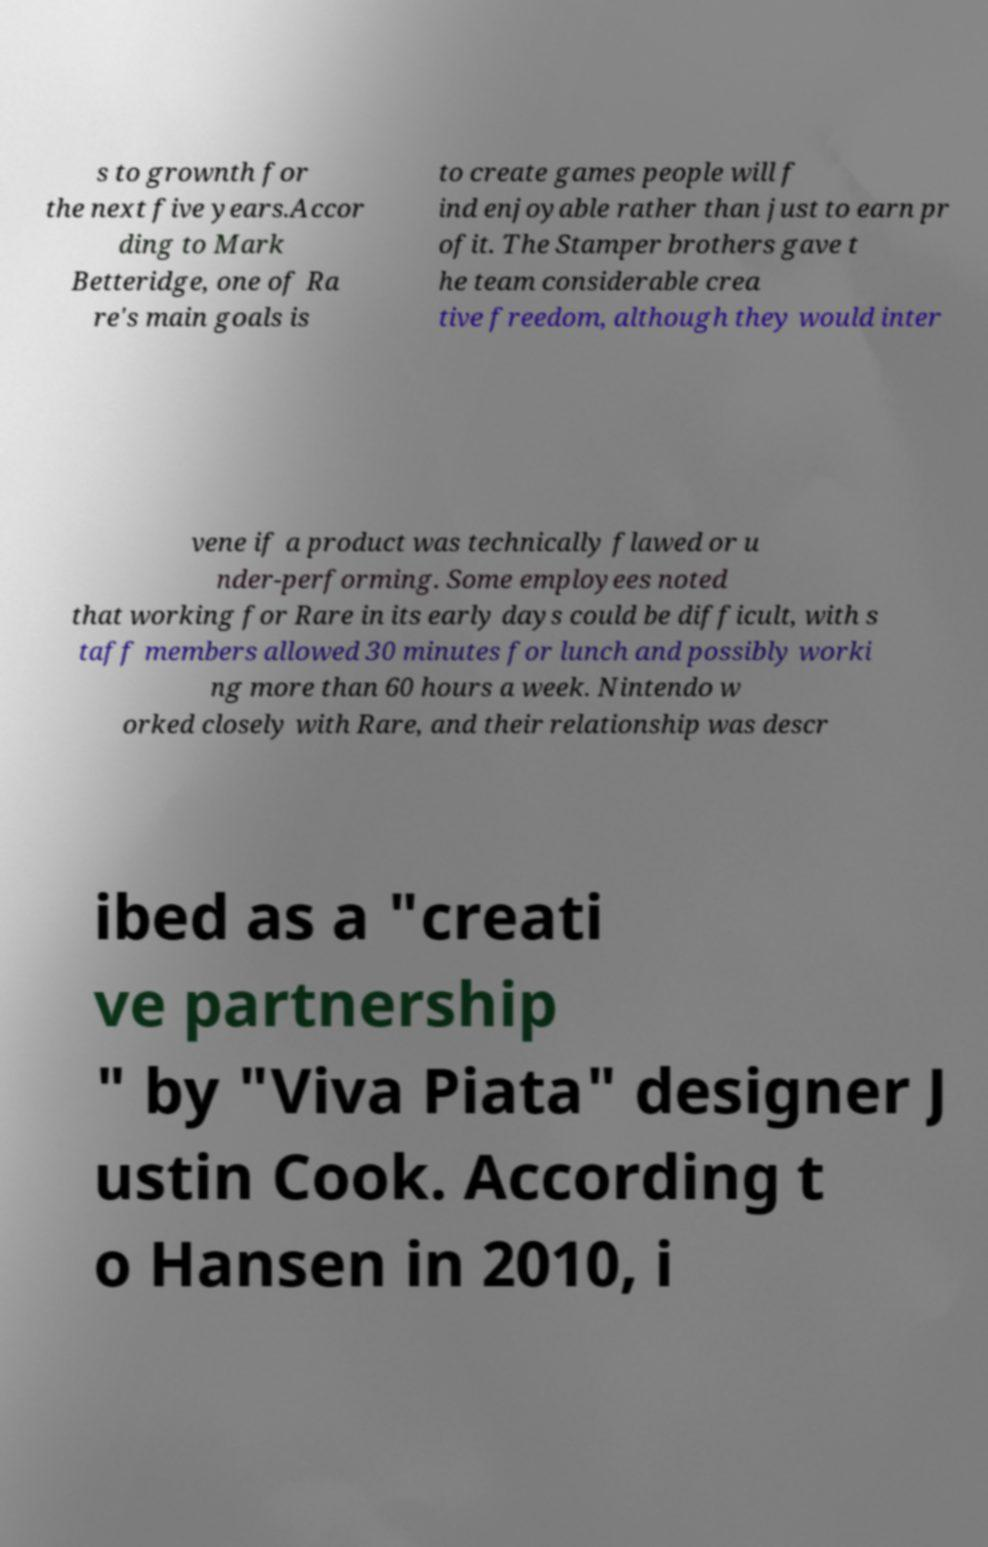Could you assist in decoding the text presented in this image and type it out clearly? s to grownth for the next five years.Accor ding to Mark Betteridge, one of Ra re's main goals is to create games people will f ind enjoyable rather than just to earn pr ofit. The Stamper brothers gave t he team considerable crea tive freedom, although they would inter vene if a product was technically flawed or u nder-performing. Some employees noted that working for Rare in its early days could be difficult, with s taff members allowed 30 minutes for lunch and possibly worki ng more than 60 hours a week. Nintendo w orked closely with Rare, and their relationship was descr ibed as a "creati ve partnership " by "Viva Piata" designer J ustin Cook. According t o Hansen in 2010, i 